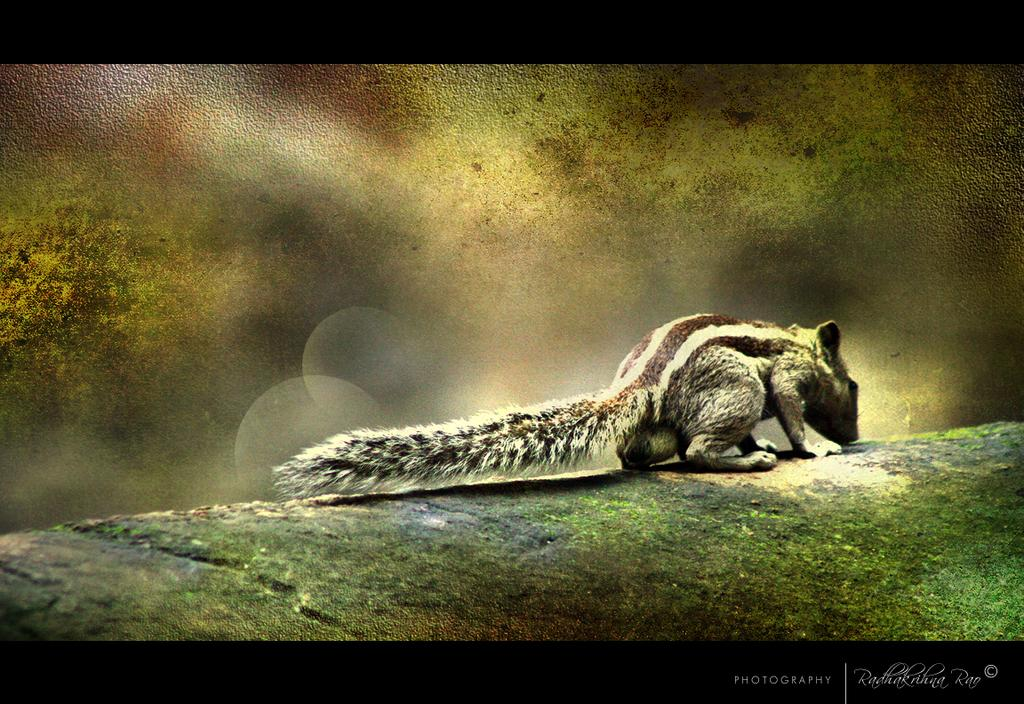What animal is in the middle of the image? There is a squirrel in the middle of the image. Can you describe any characteristics of the image? The image appears to be edited. Where is the watermark located in the image? The watermark is in the right-hand side bottom of the image. How many cows are standing in the position shown in the image? There are no cows present in the image; it features a squirrel. What type of flame can be seen in the image? There is no flame present in the image. 